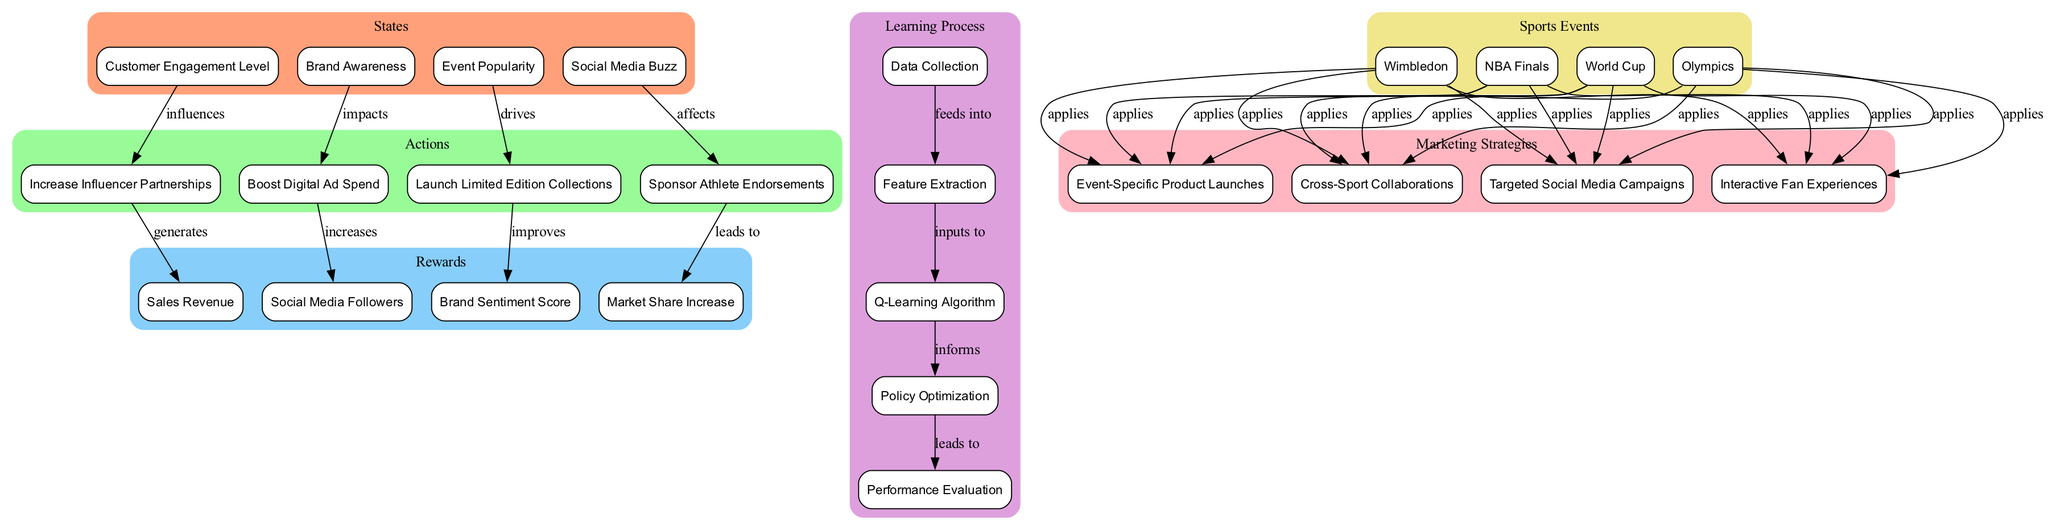What are the states represented in the diagram? The states in the diagram are explicitly listed as nodes. They are "Customer Engagement Level," "Brand Awareness," "Event Popularity," and "Social Media Buzz."
Answer: Customer Engagement Level, Brand Awareness, Event Popularity, Social Media Buzz Which action is linked to "Event Popularity"? The diagram shows the action linked to "Event Popularity" is "Launch Limited Edition Collections." This is identified by tracing the edge from "Event Popularity" to "Launch Limited Edition Collections."
Answer: Launch Limited Edition Collections How many marketing strategies are included in the diagram? By counting the nodes in the "Marketing Strategies" category, we find there are four strategies: "Targeted Social Media Campaigns," "Event-Specific Product Launches," "Interactive Fan Experiences," and "Cross-Sport Collaborations."
Answer: 4 Which reward is associated with "Sponsor Athlete Endorsements"? The diagram shows that "Sponsor Athlete Endorsements" leads to the reward "Market Share Increase," indicated by the edge connecting these two nodes.
Answer: Market Share Increase What is the first step in the learning process? The learning process is listed in a sequential manner within the diagram. The first step, based on the connections, is "Data Collection."
Answer: Data Collection What type of relationship exists between "Social Media Buzz" and "Sponsor Athlete Endorsements"? The diagram indicates that "Social Media Buzz" "affects" "Sponsor Athlete Endorsements," as noted by the edge labeled with this relationship.
Answer: affects Which sports event applies to "Interactive Fan Experiences"? The diagram illustrates that all sports events connect to "Interactive Fan Experiences," but there is no specific connection shown to only one event; instead, it implies all apply.
Answer: applies How does "Boost Digital Ad Spend" influence rewards? Following the path in the diagram, "Boost Digital Ad Spend" leads to the reward "Social Media Followers," establishing a direct influence between them, as indicated by the edge labeled "increases."
Answer: Social Media Followers What does the "Q-Learning Algorithm" feed into? The diagram indicates that "Q-Learning Algorithm" feeds into "Policy Optimization," as demonstrated by the edge linking these two nodes.
Answer: Policy Optimization 